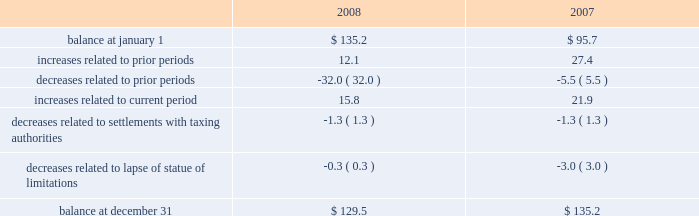Reinvested for continued use in foreign operations .
If the total undistributed earnings of foreign subsidiaries were remitted , a significant amount of the additional tax would be offset by the allowable foreign tax credits .
It is not practical for us to determine the additional tax of remitting these earnings .
In september 2007 , we reached a settlement with the united states department of justice to resolve an investigation into financial relationships between major orthopaedic manufacturers and consulting orthopaedic surgeons .
Under the terms of the settlement , we paid a civil settlement amount of $ 169.5 million and we recorded an expense in that amount .
At the time , no tax benefit was recorded related to the settlement expense due to the uncertainty as to the tax treatment .
During the third quarter of 2008 , we reached an agreement with the u.s .
Internal revenue service ( irs ) confirming the deductibility of a portion of the settlement payment .
As a result , during 2008 we recorded a current tax benefit of $ 31.7 million .
In june 2006 , the financial accounting standards board ( fasb ) issued interpretation no .
48 , accounting for uncertainty in income taxes 2013 an interpretation of fasb statement no .
109 , accounting for income taxes ( fin 48 ) .
Fin 48 addresses the determination of whether tax benefits claimed or expected to be claimed on a tax return should be recorded in the financial statements .
Under fin 48 , we may recognize the tax benefit from an uncertain tax position only if it is more likely than not that the tax position will be sustained on examination by the taxing authorities , based on the technical merits of the position .
The tax benefits recognized in the financial statements from such a position should be measured based on the largest benefit that has a greater than fifty percent likelihood of being realized upon ultimate settlement .
Fin 48 also provides guidance on derecognition , classification , interest and penalties on income taxes , accounting in interim periods and requires increased disclosures .
We adopted fin 48 on january 1 , 2007 .
Prior to the adoption of fin 48 we had a long term tax liability for expected settlement of various federal , state and foreign income tax liabilities that was reflected net of the corollary tax impact of these expected settlements of $ 102.1 million , as well as a separate accrued interest liability of $ 1.7 million .
As a result of the adoption of fin 48 , we are required to present the different components of such liability on a gross basis versus the historical net presentation .
The adoption resulted in the financial statement liability for unrecognized tax benefits decreasing by $ 6.4 million as of january 1 , 2007 .
The adoption resulted in this decrease in the liability as well as a reduction to retained earnings of $ 4.8 million , a reduction in goodwill of $ 61.4 million , the establishment of a tax receivable of $ 58.2 million , which was recorded in other current and non-current assets on our consolidated balance sheet , and an increase in an interest/penalty payable of $ 7.9 million , all as of january 1 , 2007 .
Therefore , after the adoption of fin 48 , the amount of unrecognized tax benefits is $ 95.7 million as of january 1 , 2007 .
As of december 31 , 2008 , the amount of unrecognized tax benefits is $ 129.5 million .
Of this amount , $ 45.5 million would impact our effective tax rate if recognized .
$ 38.2 million of the $ 129.5 million liability for unrecognized tax benefits relate to tax positions of acquired entities taken prior to their acquisition by us .
Under fas 141 ( r ) , if these liabilities are settled for different amounts , they will affect the income tax expense in the period of reversal or settlement .
The following is a tabular reconciliation of the total amounts of unrecognized tax benefits ( in millions ) : .
We recognize accrued interest and penalties related to unrecognized tax benefits in income tax expense in the consolidated statements of earnings , which is consistent with the recognition of these items in prior reporting periods .
As of december 31 , 2007 , we recorded a liability of $ 19.6 million for accrued interest and penalties , of which $ 14.7 million would impact our effective tax rate , if recognized .
The amount of this liability is $ 22.9 million as of december 31 , 2008 .
Of this amount , $ 17.1 million would impact our effective tax rate , if recognized .
We expect that the amount of tax liability for unrecognized tax benefits will change in the next twelve months ; however , we do not expect these changes will have a significant impact on our results of operations or financial position .
The u.s .
Federal statute of limitations remains open for the year 2003 and onward .
The u.s .
Federal returns for years 2003 and 2004 are currently under examination by the irs .
On july 15 , 2008 , the irs issued its examination report .
We filed a formal protest on august 15 , 2008 and requested a conference with the appeals office regarding disputed issues .
Although the appeals process could take several years , we do not anticipate resolution of the audit will result in any significant impact on our results of operations , financial position or cash flows .
In addition , for the 1999 tax year of centerpulse , which we acquired in october 2003 , one issue remains in dispute .
State income tax returns are generally subject to examination for a period of 3 to 5 years after filing of the respective return .
The state impact of any federal changes remains subject to examination by various states for a period of up to one year after formal notification to the states .
We have various state income tax returns in the process of examination , administrative appeals or litigation .
It is z i m m e r h o l d i n g s , i n c .
2 0 0 8 f o r m 1 0 - k a n n u a l r e p o r t notes to consolidated financial statements ( continued ) %%transmsg*** transmitting job : c48761 pcn : 057000000 ***%%pcmsg|57 |00010|yes|no|02/24/2009 06:10|0|0|page is valid , no graphics -- color : d| .
What is the change in unrecognized tax benefits between 2007 and 2008 in millions? 
Computations: (129.5 - 135.2)
Answer: -5.7. 